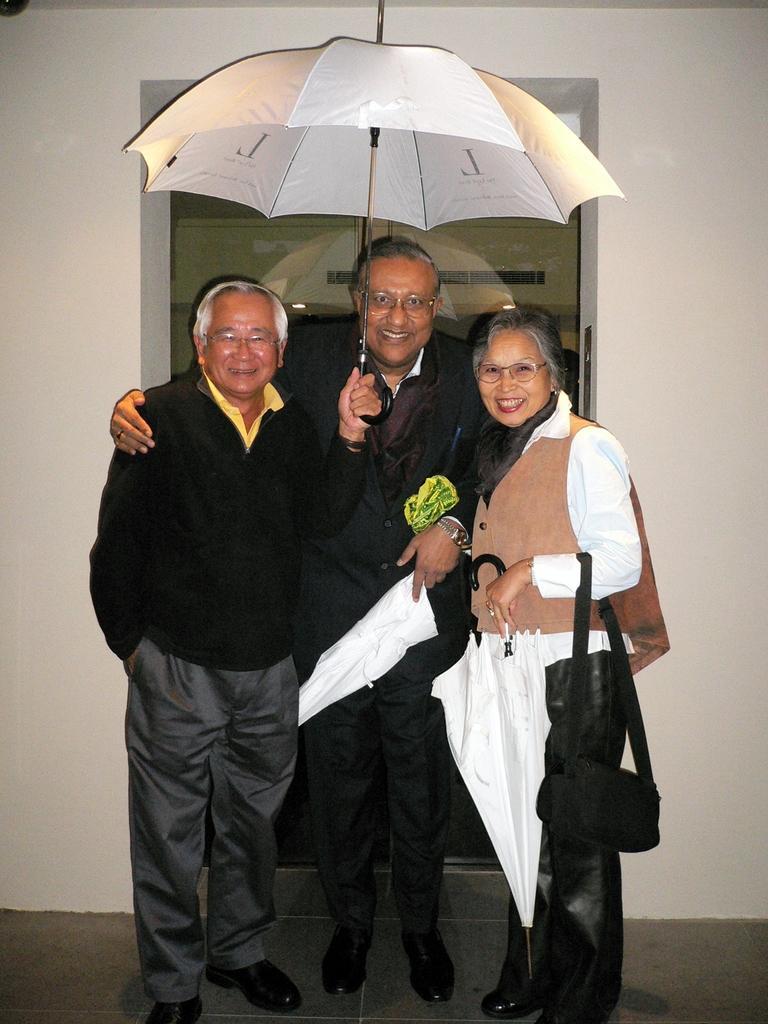In one or two sentences, can you explain what this image depicts? There are three persons standing. They are wearing specs and holding umbrellas. Lady is holding a bag. In the back there is a wall with a glass door. 